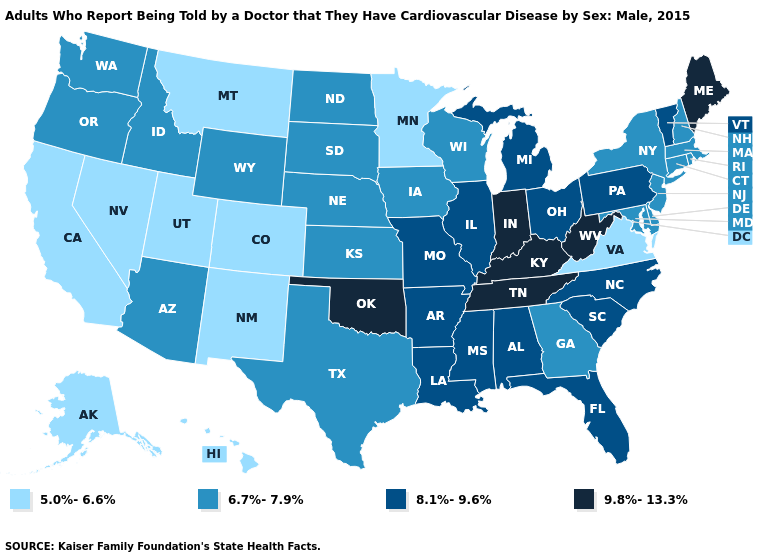Does Vermont have the highest value in the Northeast?
Write a very short answer. No. Which states hav the highest value in the Northeast?
Write a very short answer. Maine. What is the highest value in the West ?
Answer briefly. 6.7%-7.9%. What is the value of Arizona?
Short answer required. 6.7%-7.9%. Does Maryland have a lower value than Oklahoma?
Keep it brief. Yes. Which states have the lowest value in the USA?
Quick response, please. Alaska, California, Colorado, Hawaii, Minnesota, Montana, Nevada, New Mexico, Utah, Virginia. Which states have the lowest value in the West?
Be succinct. Alaska, California, Colorado, Hawaii, Montana, Nevada, New Mexico, Utah. Is the legend a continuous bar?
Answer briefly. No. What is the highest value in the MidWest ?
Be succinct. 9.8%-13.3%. Does the first symbol in the legend represent the smallest category?
Give a very brief answer. Yes. Does the first symbol in the legend represent the smallest category?
Quick response, please. Yes. Does North Dakota have the lowest value in the USA?
Be succinct. No. Does Arizona have the same value as Maryland?
Answer briefly. Yes. What is the highest value in states that border Missouri?
Concise answer only. 9.8%-13.3%. Does the first symbol in the legend represent the smallest category?
Quick response, please. Yes. 